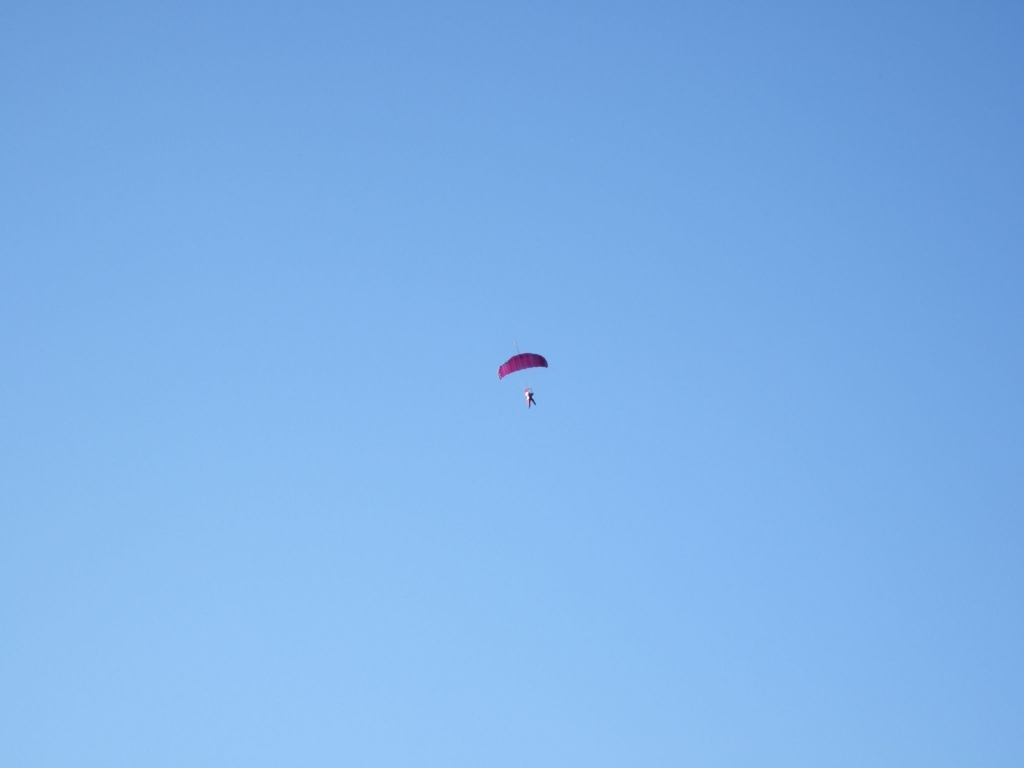How high might the paraglider be? Judging by the scale and perspective in the image, the paraglider could be approximately 1000 to 1500 feet above ground. This height allows for a broad scenic view and sufficient altitude for safe maneuvering and landing. Is this a safe altitude for beginners? Yes, this is a generally safe altitude for beginners under proper supervision. It allows enough airborne time for practice maneuvers while remaining within the safe operational limits set by paragliding schools. 